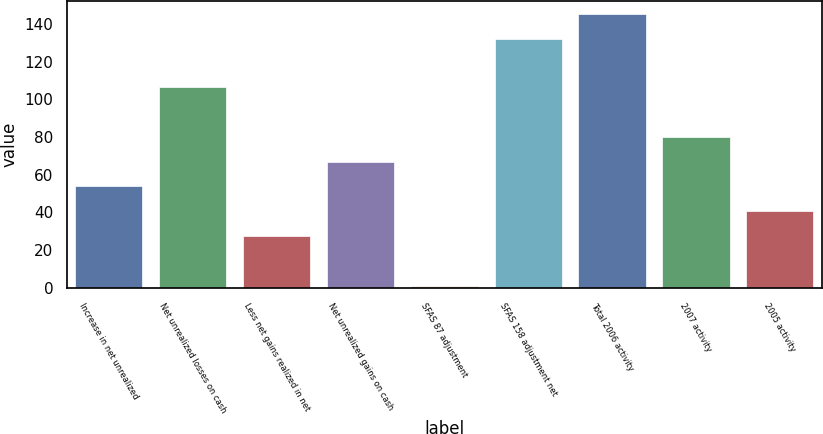<chart> <loc_0><loc_0><loc_500><loc_500><bar_chart><fcel>Increase in net unrealized<fcel>Net unrealized losses on cash<fcel>Less net gains realized in net<fcel>Net unrealized gains on cash<fcel>SFAS 87 adjustment<fcel>SFAS 158 adjustment net<fcel>Total 2006 activity<fcel>2007 activity<fcel>2005 activity<nl><fcel>53.8<fcel>106.6<fcel>27.4<fcel>67<fcel>1<fcel>132<fcel>145.2<fcel>80.2<fcel>40.6<nl></chart> 